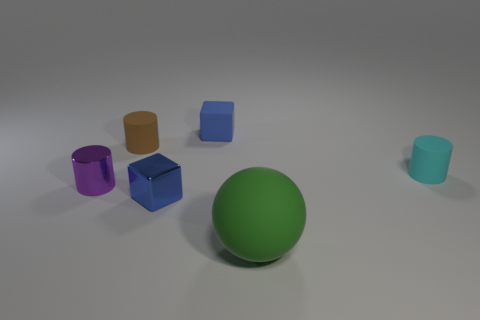Subtract all matte cylinders. How many cylinders are left? 1 Add 4 large spheres. How many objects exist? 10 Subtract all spheres. How many objects are left? 5 Subtract all blue cylinders. Subtract all yellow balls. How many cylinders are left? 3 Add 6 large green rubber objects. How many large green rubber objects are left? 7 Add 1 big green rubber balls. How many big green rubber balls exist? 2 Subtract 0 red balls. How many objects are left? 6 Subtract all tiny green cubes. Subtract all purple things. How many objects are left? 5 